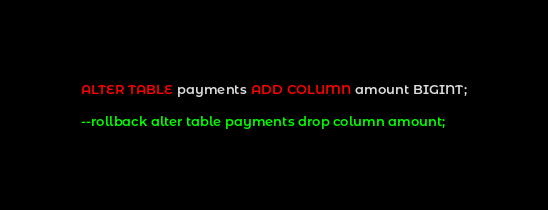<code> <loc_0><loc_0><loc_500><loc_500><_SQL_>ALTER TABLE payments ADD COLUMN amount BIGINT;

--rollback alter table payments drop column amount;
</code> 